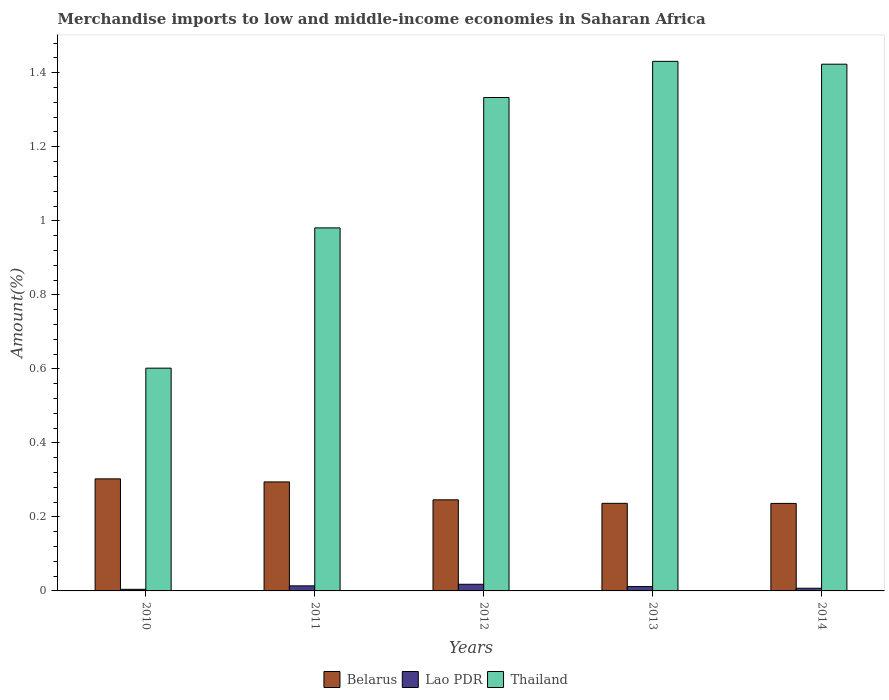How many groups of bars are there?
Give a very brief answer. 5. Are the number of bars per tick equal to the number of legend labels?
Make the answer very short. Yes. Are the number of bars on each tick of the X-axis equal?
Your answer should be compact. Yes. How many bars are there on the 4th tick from the right?
Offer a terse response. 3. What is the label of the 1st group of bars from the left?
Ensure brevity in your answer.  2010. In how many cases, is the number of bars for a given year not equal to the number of legend labels?
Provide a succinct answer. 0. What is the percentage of amount earned from merchandise imports in Lao PDR in 2011?
Your answer should be compact. 0.01. Across all years, what is the maximum percentage of amount earned from merchandise imports in Belarus?
Offer a terse response. 0.3. Across all years, what is the minimum percentage of amount earned from merchandise imports in Thailand?
Provide a short and direct response. 0.6. What is the total percentage of amount earned from merchandise imports in Belarus in the graph?
Keep it short and to the point. 1.32. What is the difference between the percentage of amount earned from merchandise imports in Lao PDR in 2011 and that in 2014?
Your answer should be compact. 0.01. What is the difference between the percentage of amount earned from merchandise imports in Belarus in 2011 and the percentage of amount earned from merchandise imports in Thailand in 2013?
Ensure brevity in your answer.  -1.14. What is the average percentage of amount earned from merchandise imports in Lao PDR per year?
Provide a short and direct response. 0.01. In the year 2012, what is the difference between the percentage of amount earned from merchandise imports in Thailand and percentage of amount earned from merchandise imports in Lao PDR?
Offer a very short reply. 1.32. What is the ratio of the percentage of amount earned from merchandise imports in Lao PDR in 2011 to that in 2014?
Offer a terse response. 1.9. Is the percentage of amount earned from merchandise imports in Belarus in 2011 less than that in 2012?
Make the answer very short. No. What is the difference between the highest and the second highest percentage of amount earned from merchandise imports in Belarus?
Ensure brevity in your answer.  0.01. What is the difference between the highest and the lowest percentage of amount earned from merchandise imports in Lao PDR?
Provide a short and direct response. 0.01. Is the sum of the percentage of amount earned from merchandise imports in Lao PDR in 2010 and 2014 greater than the maximum percentage of amount earned from merchandise imports in Belarus across all years?
Your answer should be very brief. No. What does the 2nd bar from the left in 2012 represents?
Ensure brevity in your answer.  Lao PDR. What does the 2nd bar from the right in 2012 represents?
Your response must be concise. Lao PDR. How many bars are there?
Ensure brevity in your answer.  15. How many years are there in the graph?
Your response must be concise. 5. What is the difference between two consecutive major ticks on the Y-axis?
Make the answer very short. 0.2. Are the values on the major ticks of Y-axis written in scientific E-notation?
Your response must be concise. No. Does the graph contain any zero values?
Provide a short and direct response. No. How many legend labels are there?
Ensure brevity in your answer.  3. How are the legend labels stacked?
Offer a very short reply. Horizontal. What is the title of the graph?
Ensure brevity in your answer.  Merchandise imports to low and middle-income economies in Saharan Africa. Does "Morocco" appear as one of the legend labels in the graph?
Keep it short and to the point. No. What is the label or title of the X-axis?
Provide a short and direct response. Years. What is the label or title of the Y-axis?
Give a very brief answer. Amount(%). What is the Amount(%) of Belarus in 2010?
Provide a succinct answer. 0.3. What is the Amount(%) in Lao PDR in 2010?
Your answer should be compact. 0. What is the Amount(%) of Thailand in 2010?
Offer a terse response. 0.6. What is the Amount(%) in Belarus in 2011?
Offer a very short reply. 0.29. What is the Amount(%) of Lao PDR in 2011?
Your response must be concise. 0.01. What is the Amount(%) of Thailand in 2011?
Your answer should be compact. 0.98. What is the Amount(%) of Belarus in 2012?
Provide a succinct answer. 0.25. What is the Amount(%) in Lao PDR in 2012?
Your answer should be compact. 0.02. What is the Amount(%) of Thailand in 2012?
Offer a very short reply. 1.33. What is the Amount(%) in Belarus in 2013?
Offer a very short reply. 0.24. What is the Amount(%) in Lao PDR in 2013?
Ensure brevity in your answer.  0.01. What is the Amount(%) in Thailand in 2013?
Your answer should be compact. 1.43. What is the Amount(%) in Belarus in 2014?
Your answer should be compact. 0.24. What is the Amount(%) of Lao PDR in 2014?
Provide a short and direct response. 0.01. What is the Amount(%) of Thailand in 2014?
Your answer should be very brief. 1.42. Across all years, what is the maximum Amount(%) of Belarus?
Make the answer very short. 0.3. Across all years, what is the maximum Amount(%) of Lao PDR?
Give a very brief answer. 0.02. Across all years, what is the maximum Amount(%) of Thailand?
Your answer should be compact. 1.43. Across all years, what is the minimum Amount(%) of Belarus?
Your response must be concise. 0.24. Across all years, what is the minimum Amount(%) in Lao PDR?
Ensure brevity in your answer.  0. Across all years, what is the minimum Amount(%) of Thailand?
Provide a short and direct response. 0.6. What is the total Amount(%) of Belarus in the graph?
Give a very brief answer. 1.32. What is the total Amount(%) of Lao PDR in the graph?
Offer a terse response. 0.06. What is the total Amount(%) of Thailand in the graph?
Your answer should be very brief. 5.77. What is the difference between the Amount(%) in Belarus in 2010 and that in 2011?
Your answer should be compact. 0.01. What is the difference between the Amount(%) of Lao PDR in 2010 and that in 2011?
Offer a terse response. -0.01. What is the difference between the Amount(%) of Thailand in 2010 and that in 2011?
Your answer should be very brief. -0.38. What is the difference between the Amount(%) of Belarus in 2010 and that in 2012?
Provide a short and direct response. 0.06. What is the difference between the Amount(%) of Lao PDR in 2010 and that in 2012?
Keep it short and to the point. -0.01. What is the difference between the Amount(%) in Thailand in 2010 and that in 2012?
Provide a short and direct response. -0.73. What is the difference between the Amount(%) of Belarus in 2010 and that in 2013?
Ensure brevity in your answer.  0.07. What is the difference between the Amount(%) in Lao PDR in 2010 and that in 2013?
Give a very brief answer. -0.01. What is the difference between the Amount(%) in Thailand in 2010 and that in 2013?
Your answer should be very brief. -0.83. What is the difference between the Amount(%) in Belarus in 2010 and that in 2014?
Provide a short and direct response. 0.07. What is the difference between the Amount(%) in Lao PDR in 2010 and that in 2014?
Your answer should be very brief. -0. What is the difference between the Amount(%) in Thailand in 2010 and that in 2014?
Provide a short and direct response. -0.82. What is the difference between the Amount(%) of Belarus in 2011 and that in 2012?
Offer a very short reply. 0.05. What is the difference between the Amount(%) in Lao PDR in 2011 and that in 2012?
Your answer should be very brief. -0. What is the difference between the Amount(%) in Thailand in 2011 and that in 2012?
Your response must be concise. -0.35. What is the difference between the Amount(%) of Belarus in 2011 and that in 2013?
Your response must be concise. 0.06. What is the difference between the Amount(%) in Lao PDR in 2011 and that in 2013?
Provide a succinct answer. 0. What is the difference between the Amount(%) of Thailand in 2011 and that in 2013?
Give a very brief answer. -0.45. What is the difference between the Amount(%) of Belarus in 2011 and that in 2014?
Your response must be concise. 0.06. What is the difference between the Amount(%) in Lao PDR in 2011 and that in 2014?
Keep it short and to the point. 0.01. What is the difference between the Amount(%) in Thailand in 2011 and that in 2014?
Offer a very short reply. -0.44. What is the difference between the Amount(%) of Belarus in 2012 and that in 2013?
Provide a short and direct response. 0.01. What is the difference between the Amount(%) in Lao PDR in 2012 and that in 2013?
Provide a short and direct response. 0.01. What is the difference between the Amount(%) in Thailand in 2012 and that in 2013?
Keep it short and to the point. -0.1. What is the difference between the Amount(%) in Belarus in 2012 and that in 2014?
Provide a succinct answer. 0.01. What is the difference between the Amount(%) in Lao PDR in 2012 and that in 2014?
Give a very brief answer. 0.01. What is the difference between the Amount(%) in Thailand in 2012 and that in 2014?
Your answer should be very brief. -0.09. What is the difference between the Amount(%) in Lao PDR in 2013 and that in 2014?
Give a very brief answer. 0. What is the difference between the Amount(%) of Thailand in 2013 and that in 2014?
Your answer should be very brief. 0.01. What is the difference between the Amount(%) in Belarus in 2010 and the Amount(%) in Lao PDR in 2011?
Make the answer very short. 0.29. What is the difference between the Amount(%) in Belarus in 2010 and the Amount(%) in Thailand in 2011?
Offer a very short reply. -0.68. What is the difference between the Amount(%) in Lao PDR in 2010 and the Amount(%) in Thailand in 2011?
Provide a short and direct response. -0.98. What is the difference between the Amount(%) of Belarus in 2010 and the Amount(%) of Lao PDR in 2012?
Keep it short and to the point. 0.28. What is the difference between the Amount(%) in Belarus in 2010 and the Amount(%) in Thailand in 2012?
Ensure brevity in your answer.  -1.03. What is the difference between the Amount(%) in Lao PDR in 2010 and the Amount(%) in Thailand in 2012?
Make the answer very short. -1.33. What is the difference between the Amount(%) in Belarus in 2010 and the Amount(%) in Lao PDR in 2013?
Provide a short and direct response. 0.29. What is the difference between the Amount(%) in Belarus in 2010 and the Amount(%) in Thailand in 2013?
Your answer should be very brief. -1.13. What is the difference between the Amount(%) of Lao PDR in 2010 and the Amount(%) of Thailand in 2013?
Your answer should be very brief. -1.43. What is the difference between the Amount(%) in Belarus in 2010 and the Amount(%) in Lao PDR in 2014?
Give a very brief answer. 0.3. What is the difference between the Amount(%) of Belarus in 2010 and the Amount(%) of Thailand in 2014?
Your response must be concise. -1.12. What is the difference between the Amount(%) in Lao PDR in 2010 and the Amount(%) in Thailand in 2014?
Your answer should be compact. -1.42. What is the difference between the Amount(%) in Belarus in 2011 and the Amount(%) in Lao PDR in 2012?
Your response must be concise. 0.28. What is the difference between the Amount(%) of Belarus in 2011 and the Amount(%) of Thailand in 2012?
Your answer should be very brief. -1.04. What is the difference between the Amount(%) in Lao PDR in 2011 and the Amount(%) in Thailand in 2012?
Offer a very short reply. -1.32. What is the difference between the Amount(%) of Belarus in 2011 and the Amount(%) of Lao PDR in 2013?
Offer a terse response. 0.28. What is the difference between the Amount(%) in Belarus in 2011 and the Amount(%) in Thailand in 2013?
Keep it short and to the point. -1.14. What is the difference between the Amount(%) in Lao PDR in 2011 and the Amount(%) in Thailand in 2013?
Your answer should be compact. -1.42. What is the difference between the Amount(%) in Belarus in 2011 and the Amount(%) in Lao PDR in 2014?
Keep it short and to the point. 0.29. What is the difference between the Amount(%) of Belarus in 2011 and the Amount(%) of Thailand in 2014?
Your response must be concise. -1.13. What is the difference between the Amount(%) of Lao PDR in 2011 and the Amount(%) of Thailand in 2014?
Offer a terse response. -1.41. What is the difference between the Amount(%) of Belarus in 2012 and the Amount(%) of Lao PDR in 2013?
Offer a terse response. 0.23. What is the difference between the Amount(%) in Belarus in 2012 and the Amount(%) in Thailand in 2013?
Make the answer very short. -1.18. What is the difference between the Amount(%) in Lao PDR in 2012 and the Amount(%) in Thailand in 2013?
Your response must be concise. -1.41. What is the difference between the Amount(%) of Belarus in 2012 and the Amount(%) of Lao PDR in 2014?
Give a very brief answer. 0.24. What is the difference between the Amount(%) in Belarus in 2012 and the Amount(%) in Thailand in 2014?
Offer a very short reply. -1.18. What is the difference between the Amount(%) of Lao PDR in 2012 and the Amount(%) of Thailand in 2014?
Provide a succinct answer. -1.41. What is the difference between the Amount(%) in Belarus in 2013 and the Amount(%) in Lao PDR in 2014?
Ensure brevity in your answer.  0.23. What is the difference between the Amount(%) in Belarus in 2013 and the Amount(%) in Thailand in 2014?
Make the answer very short. -1.19. What is the difference between the Amount(%) of Lao PDR in 2013 and the Amount(%) of Thailand in 2014?
Give a very brief answer. -1.41. What is the average Amount(%) of Belarus per year?
Keep it short and to the point. 0.26. What is the average Amount(%) of Lao PDR per year?
Offer a very short reply. 0.01. What is the average Amount(%) of Thailand per year?
Your answer should be very brief. 1.15. In the year 2010, what is the difference between the Amount(%) in Belarus and Amount(%) in Lao PDR?
Offer a terse response. 0.3. In the year 2010, what is the difference between the Amount(%) in Belarus and Amount(%) in Thailand?
Make the answer very short. -0.3. In the year 2010, what is the difference between the Amount(%) of Lao PDR and Amount(%) of Thailand?
Give a very brief answer. -0.6. In the year 2011, what is the difference between the Amount(%) in Belarus and Amount(%) in Lao PDR?
Offer a terse response. 0.28. In the year 2011, what is the difference between the Amount(%) in Belarus and Amount(%) in Thailand?
Offer a terse response. -0.69. In the year 2011, what is the difference between the Amount(%) in Lao PDR and Amount(%) in Thailand?
Make the answer very short. -0.97. In the year 2012, what is the difference between the Amount(%) of Belarus and Amount(%) of Lao PDR?
Your answer should be compact. 0.23. In the year 2012, what is the difference between the Amount(%) in Belarus and Amount(%) in Thailand?
Keep it short and to the point. -1.09. In the year 2012, what is the difference between the Amount(%) of Lao PDR and Amount(%) of Thailand?
Keep it short and to the point. -1.32. In the year 2013, what is the difference between the Amount(%) of Belarus and Amount(%) of Lao PDR?
Provide a succinct answer. 0.22. In the year 2013, what is the difference between the Amount(%) of Belarus and Amount(%) of Thailand?
Ensure brevity in your answer.  -1.19. In the year 2013, what is the difference between the Amount(%) of Lao PDR and Amount(%) of Thailand?
Ensure brevity in your answer.  -1.42. In the year 2014, what is the difference between the Amount(%) in Belarus and Amount(%) in Lao PDR?
Provide a short and direct response. 0.23. In the year 2014, what is the difference between the Amount(%) in Belarus and Amount(%) in Thailand?
Your answer should be compact. -1.19. In the year 2014, what is the difference between the Amount(%) of Lao PDR and Amount(%) of Thailand?
Keep it short and to the point. -1.42. What is the ratio of the Amount(%) of Belarus in 2010 to that in 2011?
Your answer should be very brief. 1.03. What is the ratio of the Amount(%) in Lao PDR in 2010 to that in 2011?
Your response must be concise. 0.32. What is the ratio of the Amount(%) in Thailand in 2010 to that in 2011?
Your response must be concise. 0.61. What is the ratio of the Amount(%) in Belarus in 2010 to that in 2012?
Provide a short and direct response. 1.23. What is the ratio of the Amount(%) of Lao PDR in 2010 to that in 2012?
Your answer should be very brief. 0.24. What is the ratio of the Amount(%) in Thailand in 2010 to that in 2012?
Ensure brevity in your answer.  0.45. What is the ratio of the Amount(%) in Belarus in 2010 to that in 2013?
Offer a very short reply. 1.28. What is the ratio of the Amount(%) of Lao PDR in 2010 to that in 2013?
Your answer should be compact. 0.37. What is the ratio of the Amount(%) in Thailand in 2010 to that in 2013?
Offer a very short reply. 0.42. What is the ratio of the Amount(%) in Belarus in 2010 to that in 2014?
Your answer should be very brief. 1.28. What is the ratio of the Amount(%) of Lao PDR in 2010 to that in 2014?
Your answer should be very brief. 0.6. What is the ratio of the Amount(%) of Thailand in 2010 to that in 2014?
Provide a short and direct response. 0.42. What is the ratio of the Amount(%) of Belarus in 2011 to that in 2012?
Offer a terse response. 1.2. What is the ratio of the Amount(%) of Lao PDR in 2011 to that in 2012?
Offer a very short reply. 0.76. What is the ratio of the Amount(%) in Thailand in 2011 to that in 2012?
Ensure brevity in your answer.  0.74. What is the ratio of the Amount(%) in Belarus in 2011 to that in 2013?
Offer a very short reply. 1.24. What is the ratio of the Amount(%) in Lao PDR in 2011 to that in 2013?
Offer a terse response. 1.16. What is the ratio of the Amount(%) of Thailand in 2011 to that in 2013?
Offer a very short reply. 0.69. What is the ratio of the Amount(%) in Belarus in 2011 to that in 2014?
Ensure brevity in your answer.  1.25. What is the ratio of the Amount(%) of Lao PDR in 2011 to that in 2014?
Your response must be concise. 1.9. What is the ratio of the Amount(%) in Thailand in 2011 to that in 2014?
Your response must be concise. 0.69. What is the ratio of the Amount(%) of Belarus in 2012 to that in 2013?
Provide a succinct answer. 1.04. What is the ratio of the Amount(%) in Lao PDR in 2012 to that in 2013?
Your response must be concise. 1.52. What is the ratio of the Amount(%) of Thailand in 2012 to that in 2013?
Ensure brevity in your answer.  0.93. What is the ratio of the Amount(%) of Belarus in 2012 to that in 2014?
Your answer should be compact. 1.04. What is the ratio of the Amount(%) in Lao PDR in 2012 to that in 2014?
Make the answer very short. 2.48. What is the ratio of the Amount(%) in Thailand in 2012 to that in 2014?
Provide a succinct answer. 0.94. What is the ratio of the Amount(%) in Belarus in 2013 to that in 2014?
Offer a very short reply. 1. What is the ratio of the Amount(%) in Lao PDR in 2013 to that in 2014?
Provide a short and direct response. 1.63. What is the ratio of the Amount(%) of Thailand in 2013 to that in 2014?
Your answer should be compact. 1.01. What is the difference between the highest and the second highest Amount(%) of Belarus?
Provide a succinct answer. 0.01. What is the difference between the highest and the second highest Amount(%) of Lao PDR?
Offer a terse response. 0. What is the difference between the highest and the second highest Amount(%) in Thailand?
Your answer should be compact. 0.01. What is the difference between the highest and the lowest Amount(%) in Belarus?
Your response must be concise. 0.07. What is the difference between the highest and the lowest Amount(%) in Lao PDR?
Your answer should be very brief. 0.01. What is the difference between the highest and the lowest Amount(%) in Thailand?
Give a very brief answer. 0.83. 